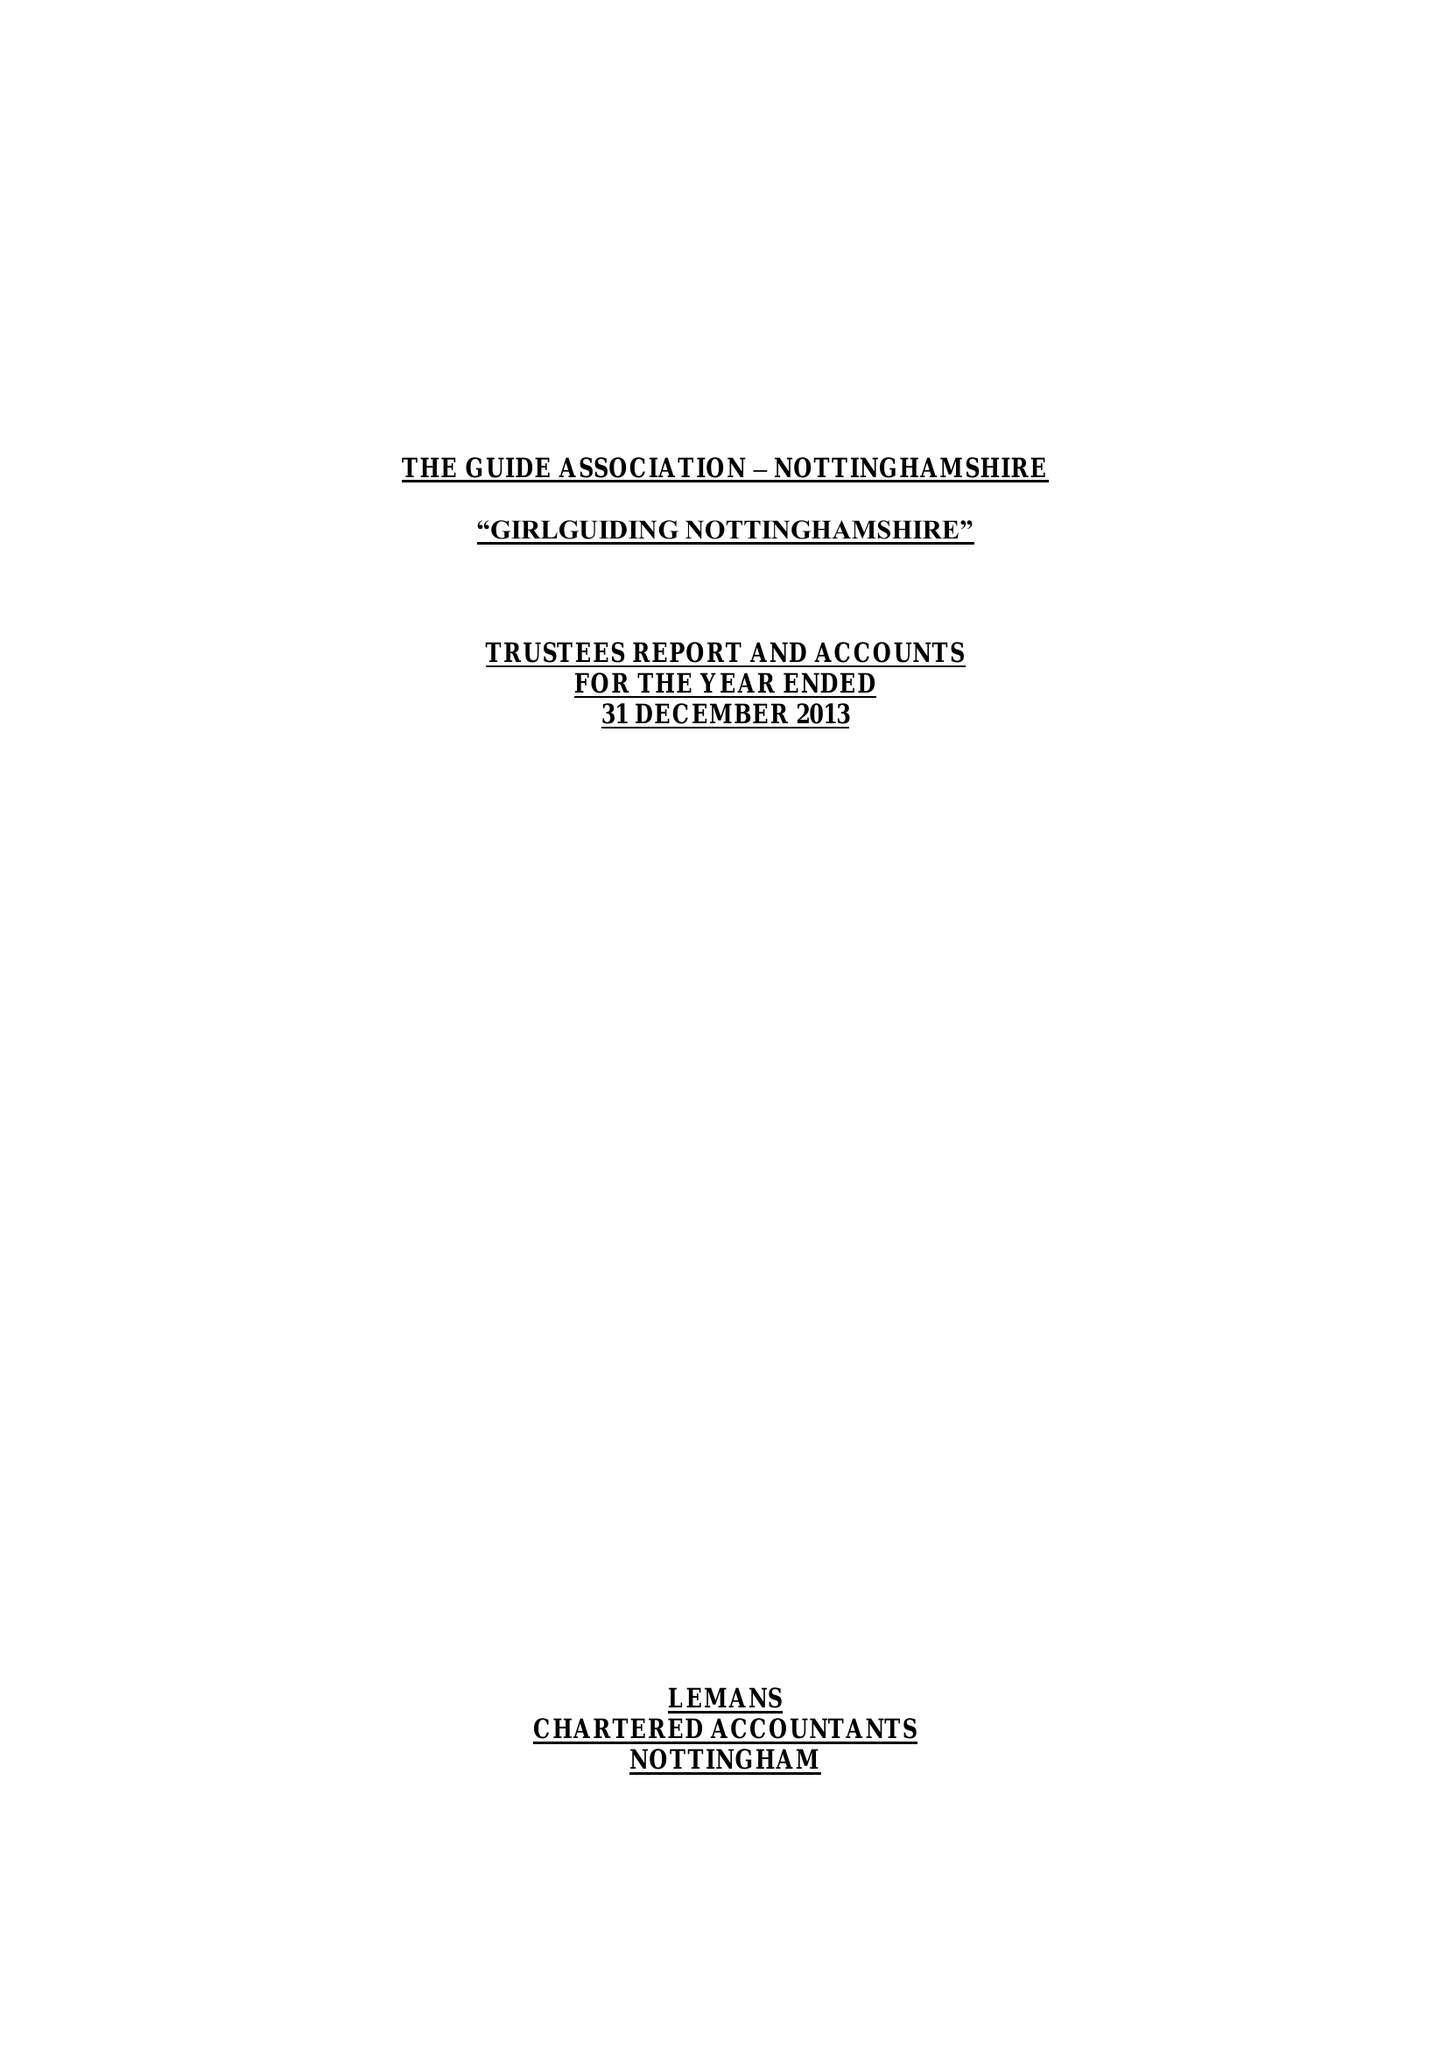What is the value for the address__postcode?
Answer the question using a single word or phrase. NG4 3DF 